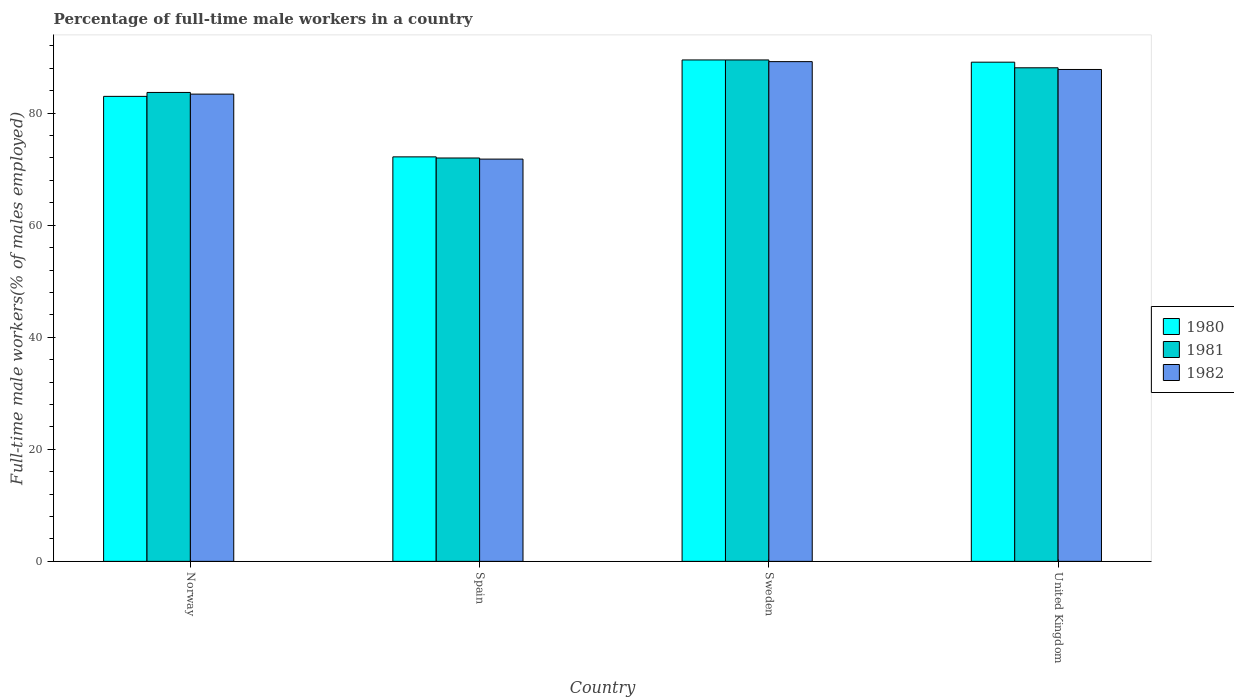How many different coloured bars are there?
Offer a terse response. 3. How many groups of bars are there?
Make the answer very short. 4. Are the number of bars on each tick of the X-axis equal?
Ensure brevity in your answer.  Yes. What is the label of the 3rd group of bars from the left?
Keep it short and to the point. Sweden. What is the percentage of full-time male workers in 1981 in United Kingdom?
Provide a short and direct response. 88.1. Across all countries, what is the maximum percentage of full-time male workers in 1982?
Provide a succinct answer. 89.2. Across all countries, what is the minimum percentage of full-time male workers in 1982?
Provide a short and direct response. 71.8. In which country was the percentage of full-time male workers in 1982 maximum?
Give a very brief answer. Sweden. In which country was the percentage of full-time male workers in 1981 minimum?
Offer a terse response. Spain. What is the total percentage of full-time male workers in 1981 in the graph?
Your answer should be compact. 333.3. What is the difference between the percentage of full-time male workers in 1980 in Spain and that in Sweden?
Keep it short and to the point. -17.3. What is the difference between the percentage of full-time male workers in 1981 in Spain and the percentage of full-time male workers in 1982 in Norway?
Make the answer very short. -11.4. What is the average percentage of full-time male workers in 1982 per country?
Your answer should be compact. 83.05. What is the difference between the percentage of full-time male workers of/in 1980 and percentage of full-time male workers of/in 1981 in United Kingdom?
Your response must be concise. 1. In how many countries, is the percentage of full-time male workers in 1980 greater than 36 %?
Ensure brevity in your answer.  4. What is the ratio of the percentage of full-time male workers in 1982 in Sweden to that in United Kingdom?
Give a very brief answer. 1.02. What is the difference between the highest and the second highest percentage of full-time male workers in 1980?
Give a very brief answer. -0.4. Is the sum of the percentage of full-time male workers in 1982 in Norway and Sweden greater than the maximum percentage of full-time male workers in 1981 across all countries?
Your response must be concise. Yes. What does the 1st bar from the right in Norway represents?
Your response must be concise. 1982. Are all the bars in the graph horizontal?
Make the answer very short. No. Where does the legend appear in the graph?
Provide a succinct answer. Center right. What is the title of the graph?
Offer a very short reply. Percentage of full-time male workers in a country. Does "2008" appear as one of the legend labels in the graph?
Give a very brief answer. No. What is the label or title of the Y-axis?
Give a very brief answer. Full-time male workers(% of males employed). What is the Full-time male workers(% of males employed) of 1980 in Norway?
Keep it short and to the point. 83. What is the Full-time male workers(% of males employed) of 1981 in Norway?
Offer a terse response. 83.7. What is the Full-time male workers(% of males employed) in 1982 in Norway?
Your answer should be compact. 83.4. What is the Full-time male workers(% of males employed) of 1980 in Spain?
Offer a terse response. 72.2. What is the Full-time male workers(% of males employed) of 1982 in Spain?
Your answer should be compact. 71.8. What is the Full-time male workers(% of males employed) in 1980 in Sweden?
Make the answer very short. 89.5. What is the Full-time male workers(% of males employed) of 1981 in Sweden?
Keep it short and to the point. 89.5. What is the Full-time male workers(% of males employed) in 1982 in Sweden?
Provide a succinct answer. 89.2. What is the Full-time male workers(% of males employed) in 1980 in United Kingdom?
Your answer should be very brief. 89.1. What is the Full-time male workers(% of males employed) in 1981 in United Kingdom?
Keep it short and to the point. 88.1. What is the Full-time male workers(% of males employed) of 1982 in United Kingdom?
Offer a terse response. 87.8. Across all countries, what is the maximum Full-time male workers(% of males employed) in 1980?
Provide a short and direct response. 89.5. Across all countries, what is the maximum Full-time male workers(% of males employed) in 1981?
Provide a short and direct response. 89.5. Across all countries, what is the maximum Full-time male workers(% of males employed) in 1982?
Ensure brevity in your answer.  89.2. Across all countries, what is the minimum Full-time male workers(% of males employed) of 1980?
Offer a terse response. 72.2. Across all countries, what is the minimum Full-time male workers(% of males employed) in 1981?
Keep it short and to the point. 72. Across all countries, what is the minimum Full-time male workers(% of males employed) in 1982?
Your answer should be compact. 71.8. What is the total Full-time male workers(% of males employed) in 1980 in the graph?
Your answer should be compact. 333.8. What is the total Full-time male workers(% of males employed) in 1981 in the graph?
Offer a very short reply. 333.3. What is the total Full-time male workers(% of males employed) of 1982 in the graph?
Give a very brief answer. 332.2. What is the difference between the Full-time male workers(% of males employed) in 1981 in Norway and that in Spain?
Give a very brief answer. 11.7. What is the difference between the Full-time male workers(% of males employed) of 1982 in Norway and that in Spain?
Provide a succinct answer. 11.6. What is the difference between the Full-time male workers(% of males employed) of 1980 in Norway and that in United Kingdom?
Ensure brevity in your answer.  -6.1. What is the difference between the Full-time male workers(% of males employed) of 1982 in Norway and that in United Kingdom?
Your answer should be very brief. -4.4. What is the difference between the Full-time male workers(% of males employed) of 1980 in Spain and that in Sweden?
Provide a succinct answer. -17.3. What is the difference between the Full-time male workers(% of males employed) in 1981 in Spain and that in Sweden?
Offer a very short reply. -17.5. What is the difference between the Full-time male workers(% of males employed) in 1982 in Spain and that in Sweden?
Your answer should be very brief. -17.4. What is the difference between the Full-time male workers(% of males employed) of 1980 in Spain and that in United Kingdom?
Your answer should be compact. -16.9. What is the difference between the Full-time male workers(% of males employed) in 1981 in Spain and that in United Kingdom?
Make the answer very short. -16.1. What is the difference between the Full-time male workers(% of males employed) in 1980 in Sweden and that in United Kingdom?
Your response must be concise. 0.4. What is the difference between the Full-time male workers(% of males employed) in 1981 in Sweden and that in United Kingdom?
Offer a very short reply. 1.4. What is the difference between the Full-time male workers(% of males employed) in 1980 in Norway and the Full-time male workers(% of males employed) in 1982 in Spain?
Make the answer very short. 11.2. What is the difference between the Full-time male workers(% of males employed) in 1980 in Norway and the Full-time male workers(% of males employed) in 1981 in Sweden?
Provide a short and direct response. -6.5. What is the difference between the Full-time male workers(% of males employed) of 1980 in Norway and the Full-time male workers(% of males employed) of 1982 in Sweden?
Keep it short and to the point. -6.2. What is the difference between the Full-time male workers(% of males employed) in 1980 in Norway and the Full-time male workers(% of males employed) in 1982 in United Kingdom?
Offer a very short reply. -4.8. What is the difference between the Full-time male workers(% of males employed) in 1980 in Spain and the Full-time male workers(% of males employed) in 1981 in Sweden?
Offer a very short reply. -17.3. What is the difference between the Full-time male workers(% of males employed) in 1981 in Spain and the Full-time male workers(% of males employed) in 1982 in Sweden?
Give a very brief answer. -17.2. What is the difference between the Full-time male workers(% of males employed) of 1980 in Spain and the Full-time male workers(% of males employed) of 1981 in United Kingdom?
Your answer should be very brief. -15.9. What is the difference between the Full-time male workers(% of males employed) in 1980 in Spain and the Full-time male workers(% of males employed) in 1982 in United Kingdom?
Give a very brief answer. -15.6. What is the difference between the Full-time male workers(% of males employed) of 1981 in Spain and the Full-time male workers(% of males employed) of 1982 in United Kingdom?
Make the answer very short. -15.8. What is the difference between the Full-time male workers(% of males employed) of 1980 in Sweden and the Full-time male workers(% of males employed) of 1981 in United Kingdom?
Keep it short and to the point. 1.4. What is the difference between the Full-time male workers(% of males employed) of 1980 in Sweden and the Full-time male workers(% of males employed) of 1982 in United Kingdom?
Keep it short and to the point. 1.7. What is the average Full-time male workers(% of males employed) in 1980 per country?
Make the answer very short. 83.45. What is the average Full-time male workers(% of males employed) of 1981 per country?
Make the answer very short. 83.33. What is the average Full-time male workers(% of males employed) of 1982 per country?
Your response must be concise. 83.05. What is the difference between the Full-time male workers(% of males employed) in 1980 and Full-time male workers(% of males employed) in 1982 in Norway?
Offer a terse response. -0.4. What is the difference between the Full-time male workers(% of males employed) in 1980 and Full-time male workers(% of males employed) in 1982 in Spain?
Keep it short and to the point. 0.4. What is the difference between the Full-time male workers(% of males employed) of 1980 and Full-time male workers(% of males employed) of 1982 in Sweden?
Your answer should be very brief. 0.3. What is the difference between the Full-time male workers(% of males employed) of 1981 and Full-time male workers(% of males employed) of 1982 in Sweden?
Give a very brief answer. 0.3. What is the difference between the Full-time male workers(% of males employed) of 1980 and Full-time male workers(% of males employed) of 1981 in United Kingdom?
Keep it short and to the point. 1. What is the ratio of the Full-time male workers(% of males employed) in 1980 in Norway to that in Spain?
Keep it short and to the point. 1.15. What is the ratio of the Full-time male workers(% of males employed) in 1981 in Norway to that in Spain?
Make the answer very short. 1.16. What is the ratio of the Full-time male workers(% of males employed) of 1982 in Norway to that in Spain?
Ensure brevity in your answer.  1.16. What is the ratio of the Full-time male workers(% of males employed) of 1980 in Norway to that in Sweden?
Offer a very short reply. 0.93. What is the ratio of the Full-time male workers(% of males employed) of 1981 in Norway to that in Sweden?
Keep it short and to the point. 0.94. What is the ratio of the Full-time male workers(% of males employed) of 1982 in Norway to that in Sweden?
Your answer should be very brief. 0.94. What is the ratio of the Full-time male workers(% of males employed) of 1980 in Norway to that in United Kingdom?
Provide a succinct answer. 0.93. What is the ratio of the Full-time male workers(% of males employed) of 1981 in Norway to that in United Kingdom?
Make the answer very short. 0.95. What is the ratio of the Full-time male workers(% of males employed) of 1982 in Norway to that in United Kingdom?
Give a very brief answer. 0.95. What is the ratio of the Full-time male workers(% of males employed) of 1980 in Spain to that in Sweden?
Provide a succinct answer. 0.81. What is the ratio of the Full-time male workers(% of males employed) of 1981 in Spain to that in Sweden?
Keep it short and to the point. 0.8. What is the ratio of the Full-time male workers(% of males employed) in 1982 in Spain to that in Sweden?
Make the answer very short. 0.8. What is the ratio of the Full-time male workers(% of males employed) in 1980 in Spain to that in United Kingdom?
Ensure brevity in your answer.  0.81. What is the ratio of the Full-time male workers(% of males employed) of 1981 in Spain to that in United Kingdom?
Your answer should be very brief. 0.82. What is the ratio of the Full-time male workers(% of males employed) of 1982 in Spain to that in United Kingdom?
Your answer should be very brief. 0.82. What is the ratio of the Full-time male workers(% of males employed) in 1981 in Sweden to that in United Kingdom?
Your answer should be very brief. 1.02. What is the ratio of the Full-time male workers(% of males employed) in 1982 in Sweden to that in United Kingdom?
Make the answer very short. 1.02. What is the difference between the highest and the second highest Full-time male workers(% of males employed) of 1982?
Offer a very short reply. 1.4. 